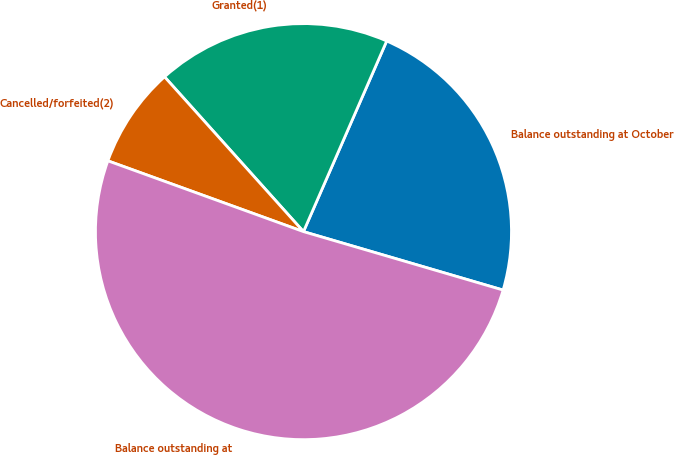<chart> <loc_0><loc_0><loc_500><loc_500><pie_chart><fcel>Balance outstanding at October<fcel>Granted(1)<fcel>Cancelled/forfeited(2)<fcel>Balance outstanding at<nl><fcel>22.98%<fcel>18.19%<fcel>7.83%<fcel>50.99%<nl></chart> 